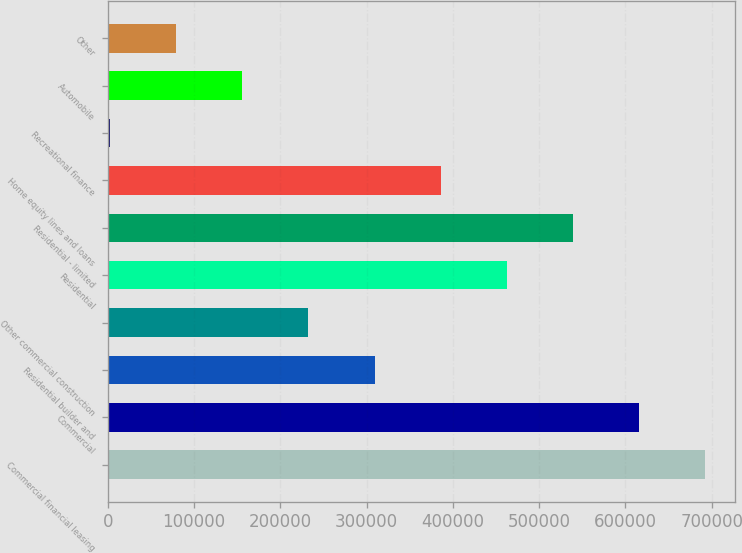Convert chart. <chart><loc_0><loc_0><loc_500><loc_500><bar_chart><fcel>Commercial financial leasing<fcel>Commercial<fcel>Residential builder and<fcel>Other commercial construction<fcel>Residential<fcel>Residential - limited<fcel>Home equity lines and loans<fcel>Recreational finance<fcel>Automobile<fcel>Other<nl><fcel>692588<fcel>615917<fcel>309233<fcel>232562<fcel>462575<fcel>539246<fcel>385904<fcel>2549<fcel>155891<fcel>79220<nl></chart> 